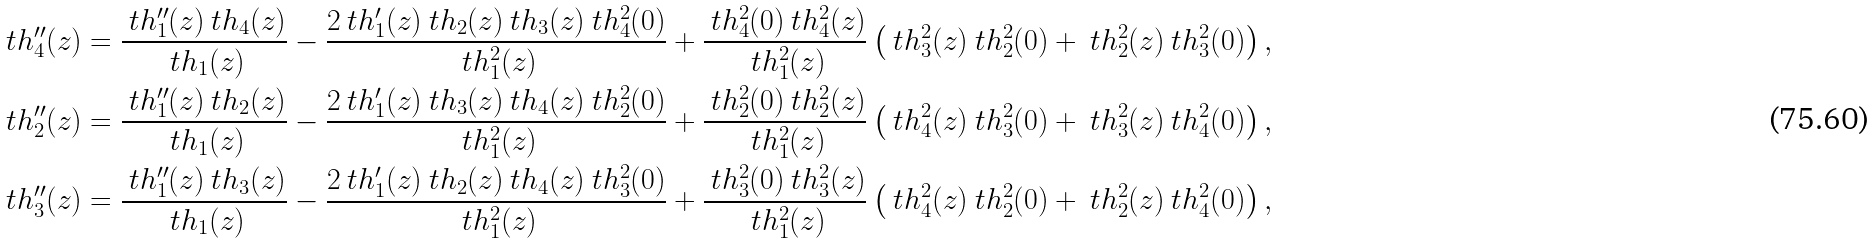<formula> <loc_0><loc_0><loc_500><loc_500>\ t h _ { 4 } ^ { \prime \prime } ( z ) & = \frac { \ t h _ { 1 } ^ { \prime \prime } ( z ) \ t h _ { 4 } ( z ) } { \ t h _ { 1 } ( z ) } - \frac { 2 \ t h _ { 1 } ^ { \prime } ( z ) \ t h _ { 2 } ( z ) \ t h _ { 3 } ( z ) \ t h _ { 4 } ^ { 2 } ( 0 ) } { \ t h _ { 1 } ^ { 2 } ( z ) } + \frac { \ t h _ { 4 } ^ { 2 } ( 0 ) \ t h _ { 4 } ^ { 2 } ( z ) } { \ t h _ { 1 } ^ { 2 } ( z ) } \left ( \ t h _ { 3 } ^ { 2 } ( z ) \ t h _ { 2 } ^ { 2 } ( 0 ) + \ t h _ { 2 } ^ { 2 } ( z ) \ t h _ { 3 } ^ { 2 } ( 0 ) \right ) , \\ \ t h _ { 2 } ^ { \prime \prime } ( z ) & = \frac { \ t h _ { 1 } ^ { \prime \prime } ( z ) \ t h _ { 2 } ( z ) } { \ t h _ { 1 } ( z ) } - \frac { 2 \ t h _ { 1 } ^ { \prime } ( z ) \ t h _ { 3 } ( z ) \ t h _ { 4 } ( z ) \ t h _ { 2 } ^ { 2 } ( 0 ) } { \ t h _ { 1 } ^ { 2 } ( z ) } + \frac { \ t h _ { 2 } ^ { 2 } ( 0 ) \ t h _ { 2 } ^ { 2 } ( z ) } { \ t h _ { 1 } ^ { 2 } ( z ) } \left ( \ t h _ { 4 } ^ { 2 } ( z ) \ t h _ { 3 } ^ { 2 } ( 0 ) + \ t h _ { 3 } ^ { 2 } ( z ) \ t h _ { 4 } ^ { 2 } ( 0 ) \right ) , \\ \ t h _ { 3 } ^ { \prime \prime } ( z ) & = \frac { \ t h _ { 1 } ^ { \prime \prime } ( z ) \ t h _ { 3 } ( z ) } { \ t h _ { 1 } ( z ) } - \frac { 2 \ t h _ { 1 } ^ { \prime } ( z ) \ t h _ { 2 } ( z ) \ t h _ { 4 } ( z ) \ t h _ { 3 } ^ { 2 } ( 0 ) } { \ t h _ { 1 } ^ { 2 } ( z ) } + \frac { \ t h _ { 3 } ^ { 2 } ( 0 ) \ t h _ { 3 } ^ { 2 } ( z ) } { \ t h _ { 1 } ^ { 2 } ( z ) } \left ( \ t h _ { 4 } ^ { 2 } ( z ) \ t h _ { 2 } ^ { 2 } ( 0 ) + \ t h _ { 2 } ^ { 2 } ( z ) \ t h _ { 4 } ^ { 2 } ( 0 ) \right ) ,</formula> 